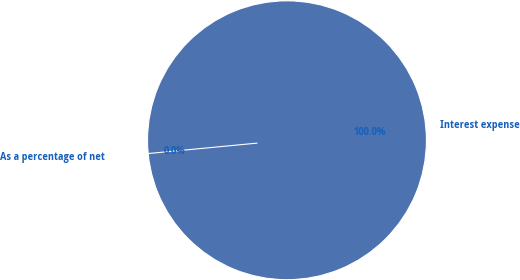Convert chart. <chart><loc_0><loc_0><loc_500><loc_500><pie_chart><fcel>Interest expense<fcel>As a percentage of net<nl><fcel>100.0%<fcel>0.0%<nl></chart> 